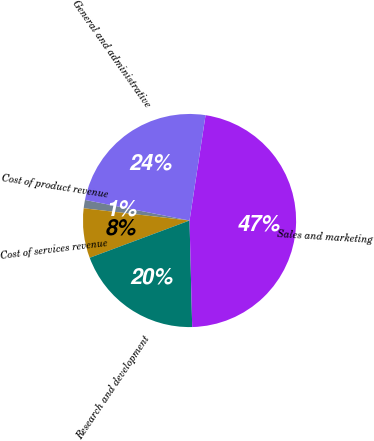<chart> <loc_0><loc_0><loc_500><loc_500><pie_chart><fcel>Cost of product revenue<fcel>Cost of services revenue<fcel>Research and development<fcel>Sales and marketing<fcel>General and administrative<nl><fcel>1.26%<fcel>7.52%<fcel>19.71%<fcel>47.2%<fcel>24.31%<nl></chart> 